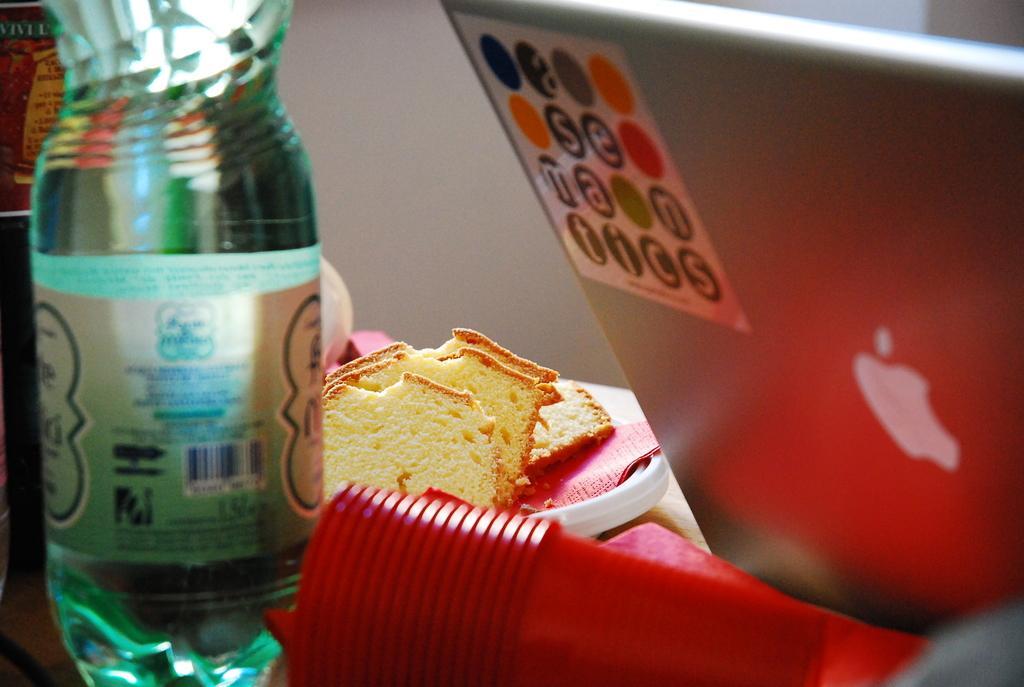Can you describe this image briefly? This image consists of a laptop, glasses in the bottom, bottle on the left side and a plate with bread pieces. Laptop is on the right side. 